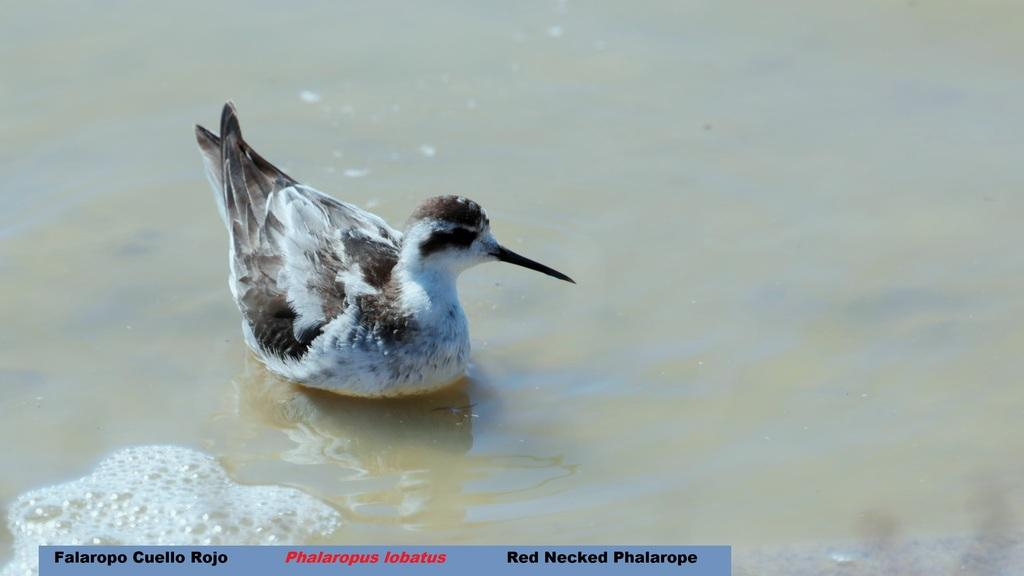What type of animal is in the water in the image? There is a bird in the water in the image. Is there any text present in the image? Yes, there is text at the bottom of the image. Where is the squirrel sitting on the sidewalk in the image? There is no squirrel or sidewalk present in the image. What part of the bird is visible in the image? The image only shows the bird in the water, so it is not possible to determine which part of the bird is visible. 